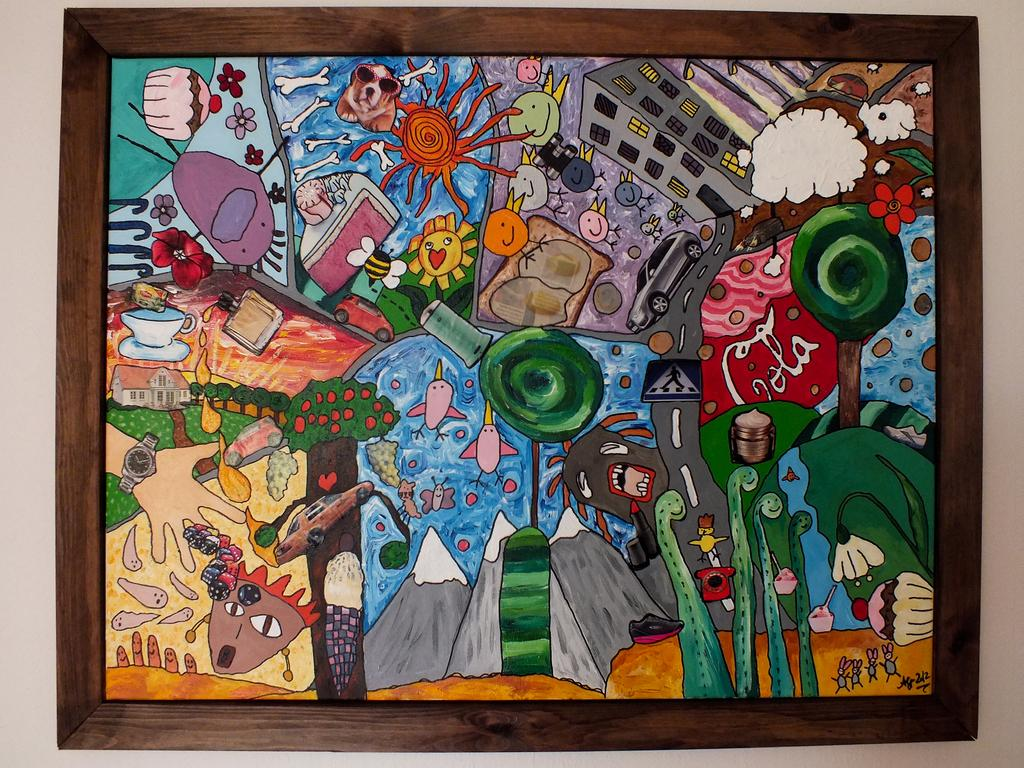What is the main subject of the image? The main subject of the image is a frame. What is inside the frame? The frame contains a painting. What does the painting depict? The painting depicts buildings, cars, a watch, a cup, biomes, and various other objects. Can you tell me how many donkeys are depicted in the painting? There are no donkeys depicted in the painting; it features buildings, cars, a watch, a cup, biomes, and various other objects. What type of dime is shown in the painting? There is no dime present in the painting; it does not contain any currency or coins. 